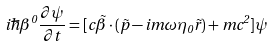<formula> <loc_0><loc_0><loc_500><loc_500>i \hbar { \beta } ^ { 0 } \frac { \partial \psi } { \partial t } = [ c \vec { \beta } \cdot ( \vec { p } - i m \omega \eta _ { 0 } \vec { r } ) + m c ^ { 2 } ] \psi</formula> 